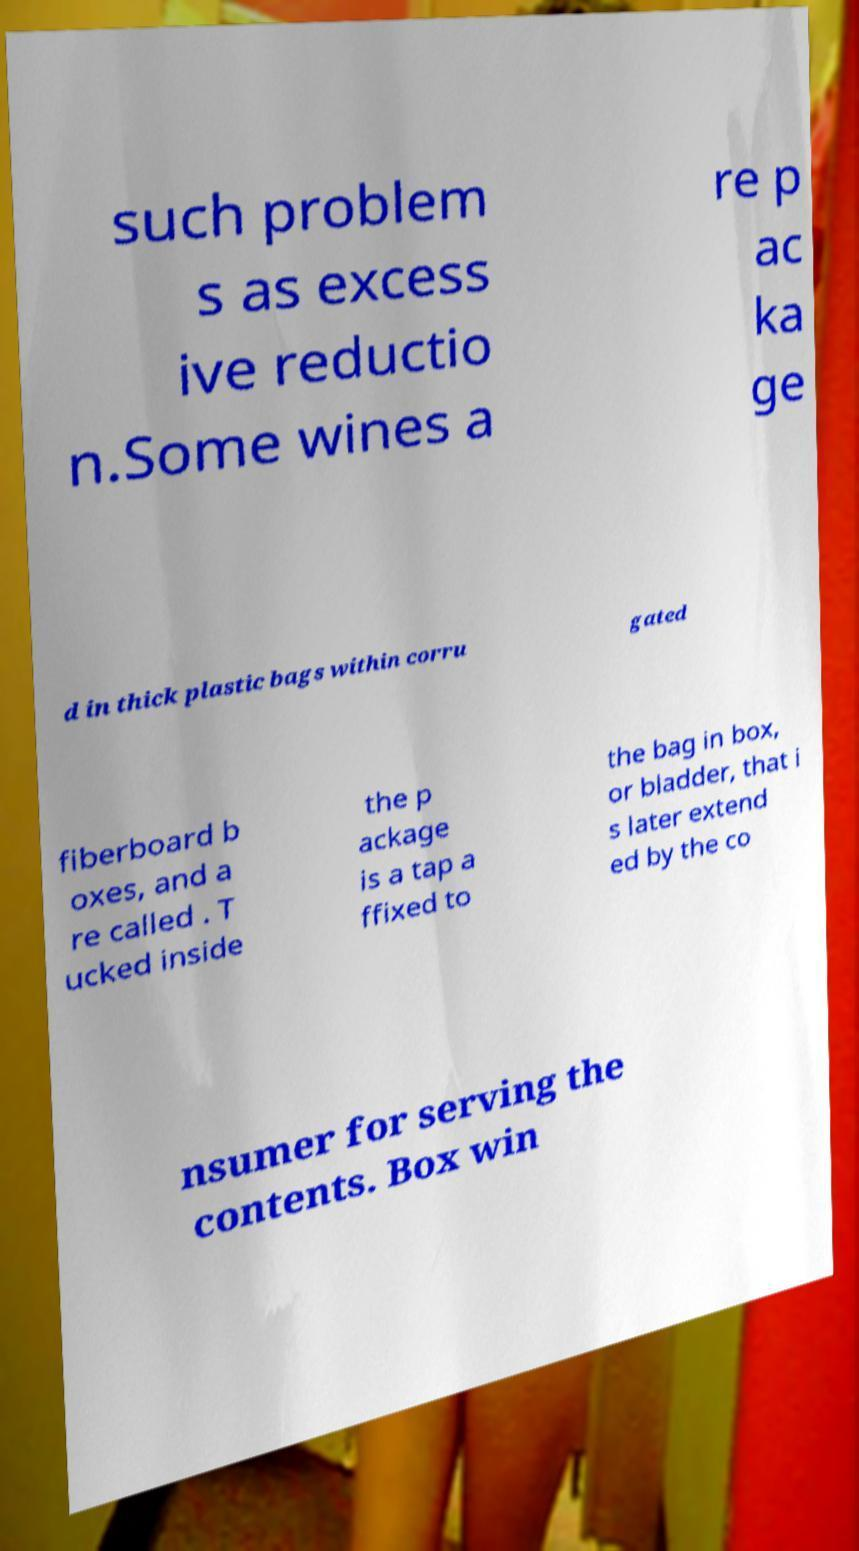Could you assist in decoding the text presented in this image and type it out clearly? such problem s as excess ive reductio n.Some wines a re p ac ka ge d in thick plastic bags within corru gated fiberboard b oxes, and a re called . T ucked inside the p ackage is a tap a ffixed to the bag in box, or bladder, that i s later extend ed by the co nsumer for serving the contents. Box win 